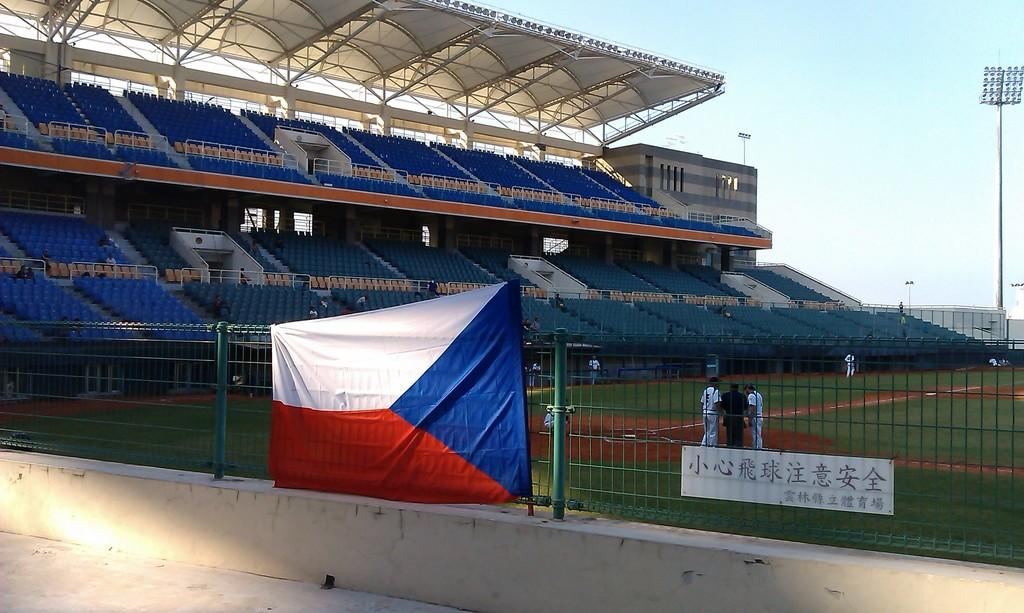<image>
Provide a brief description of the given image. A ballplayer behind a metal fence wears a number 5 uniform. 